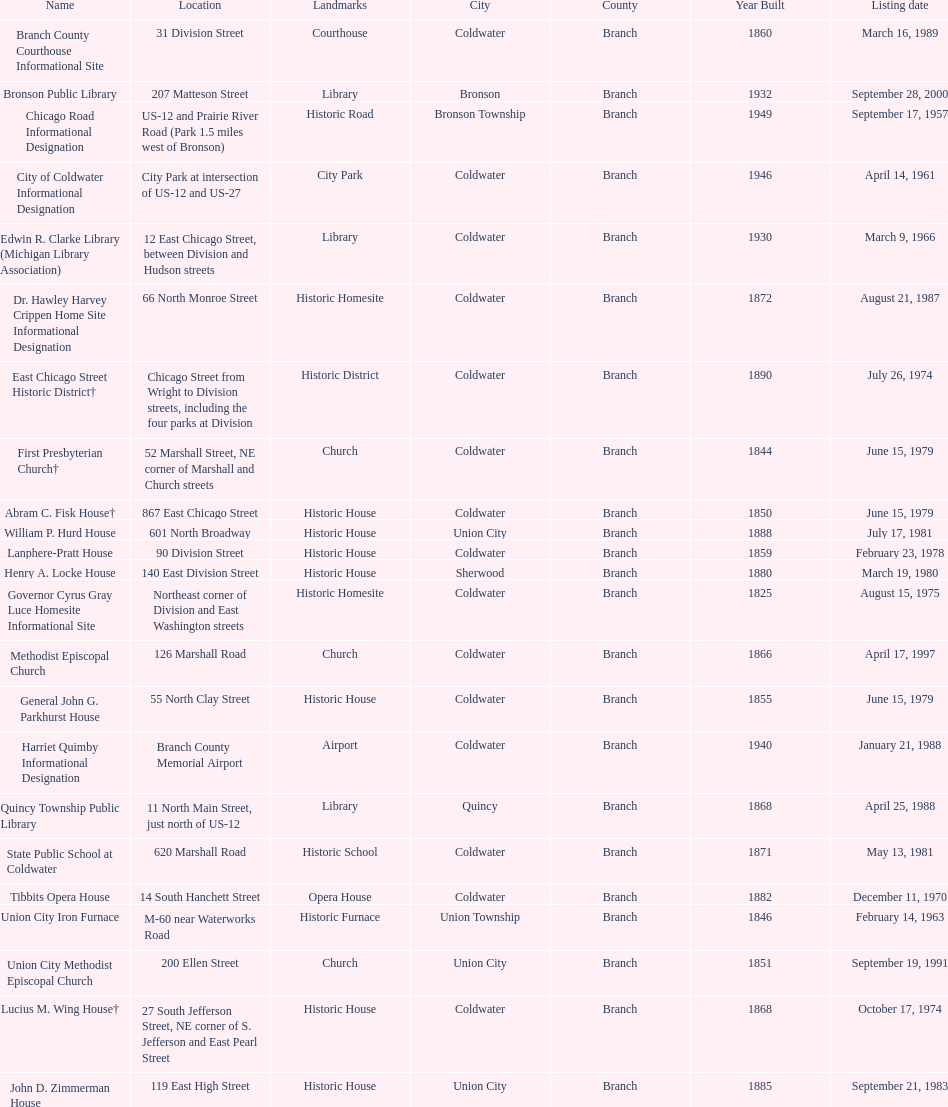How many historic sites are listed in coldwater? 15. 